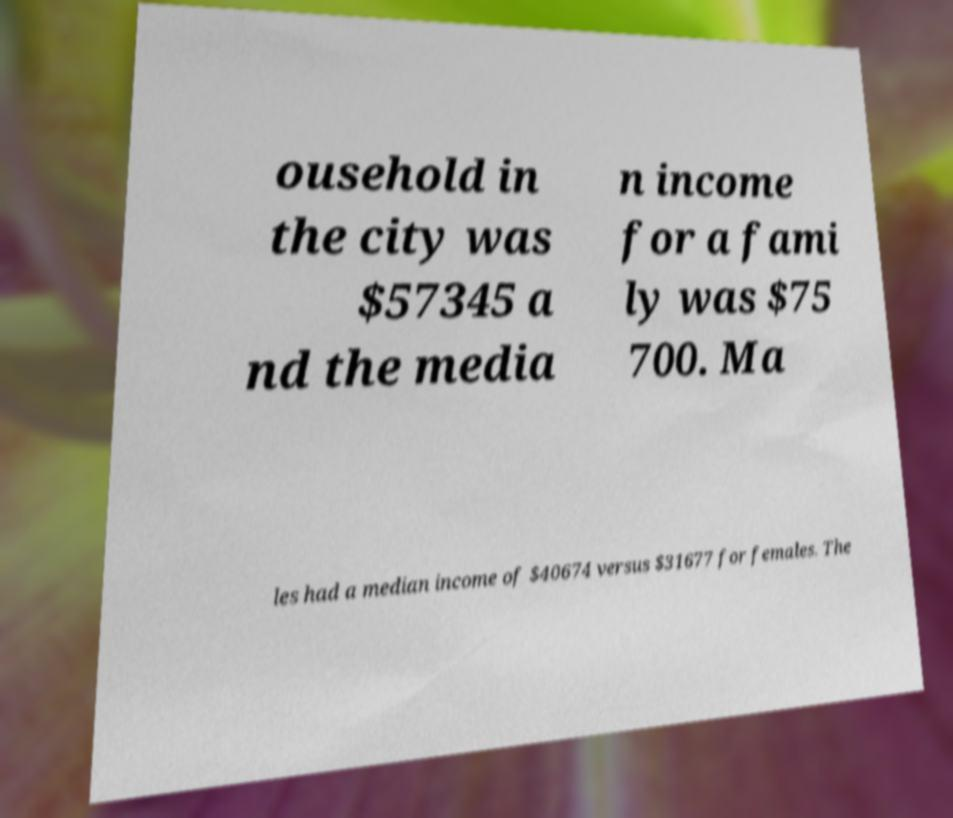Can you read and provide the text displayed in the image?This photo seems to have some interesting text. Can you extract and type it out for me? ousehold in the city was $57345 a nd the media n income for a fami ly was $75 700. Ma les had a median income of $40674 versus $31677 for females. The 